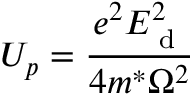Convert formula to latex. <formula><loc_0><loc_0><loc_500><loc_500>U _ { p } = \frac { e ^ { 2 } E _ { d } ^ { 2 } } { 4 m ^ { * } \Omega ^ { 2 } }</formula> 